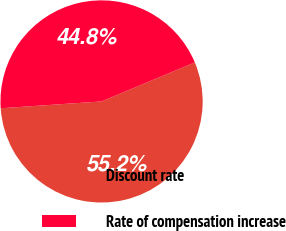<chart> <loc_0><loc_0><loc_500><loc_500><pie_chart><fcel>Discount rate<fcel>Rate of compensation increase<nl><fcel>55.23%<fcel>44.77%<nl></chart> 